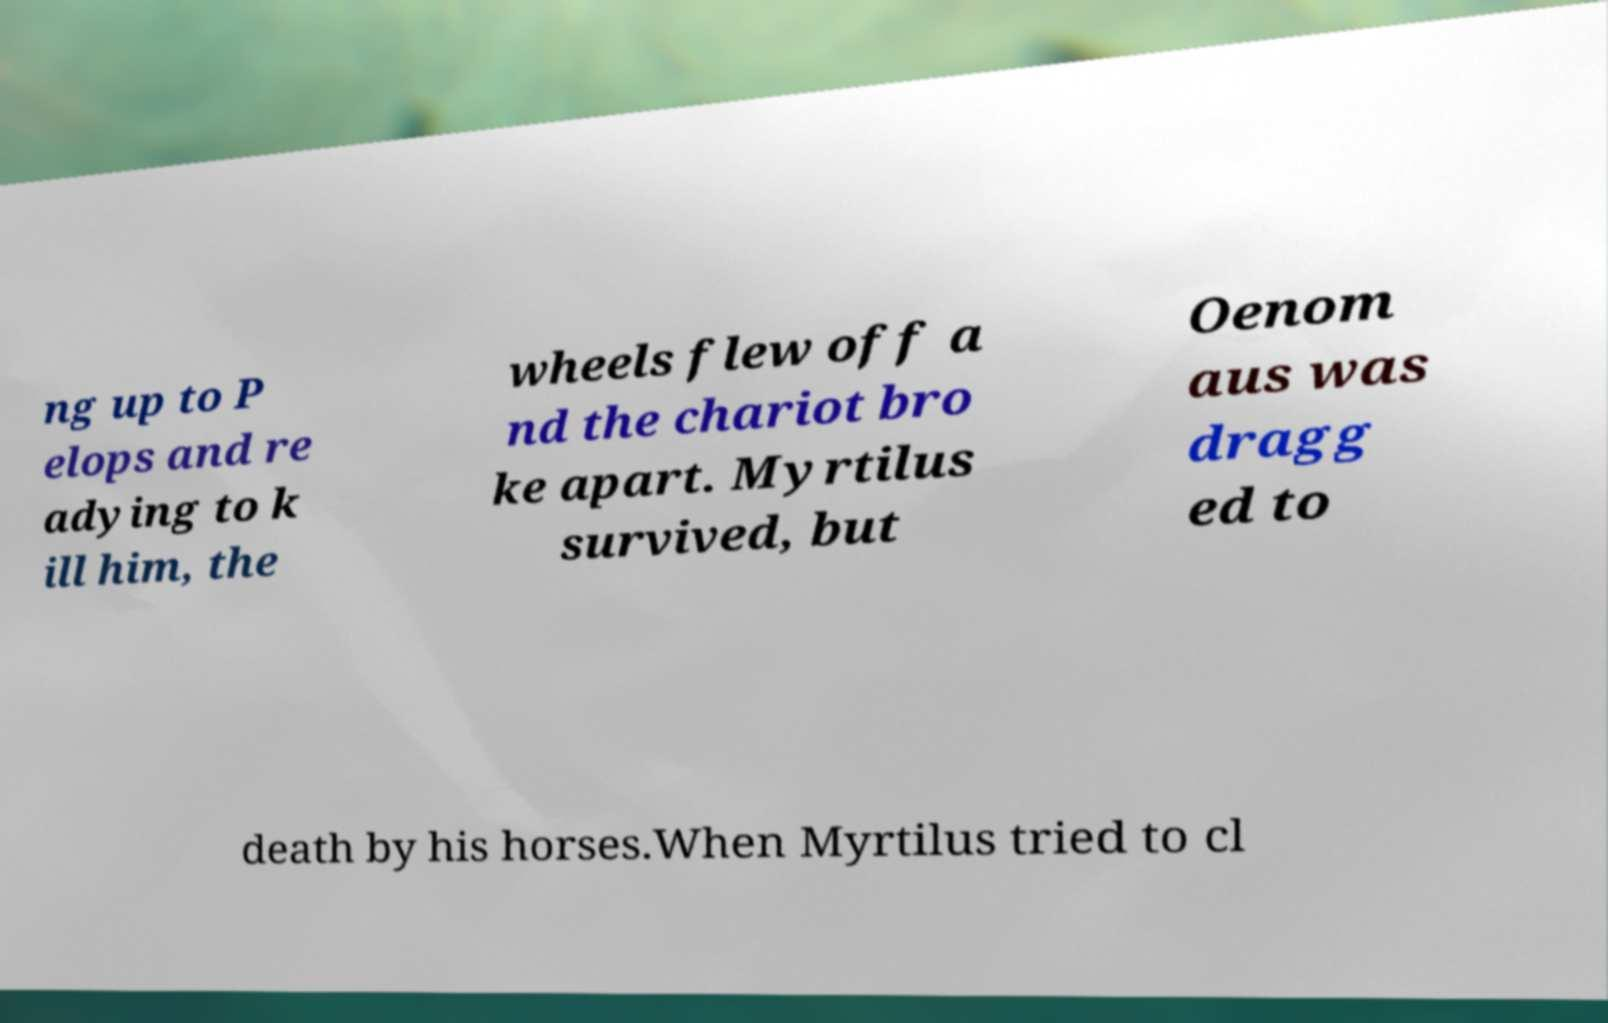There's text embedded in this image that I need extracted. Can you transcribe it verbatim? ng up to P elops and re adying to k ill him, the wheels flew off a nd the chariot bro ke apart. Myrtilus survived, but Oenom aus was dragg ed to death by his horses.When Myrtilus tried to cl 